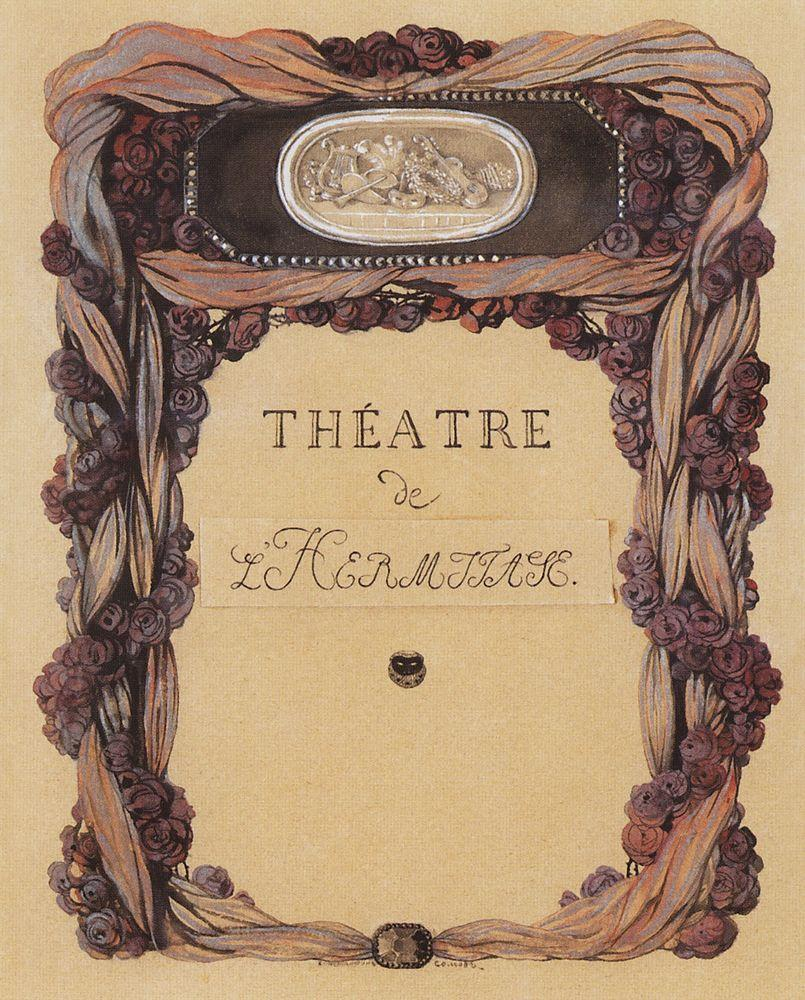What does the mirrored scene in the poster tell us about the possible themes of the play advertised? The mirrored scene displaying a man and a woman in a serene garden likely hints at themes of love, reflection, or a nature-connected narrative. The mirror may symbolize self-reflection or the multiple layers of human emotion and interaction, common in dramatic and romantic plays. Given the reflective quality of the mirror and the intimate setting, it might suggest a play exploring personal relationships, identity, or a return to one's roots in nature. This complements the overall aesthetic of the poster and may reflect the theatrical offerings that resonate with Art Nouveau's emphasis on depth and naturalistic elements. 